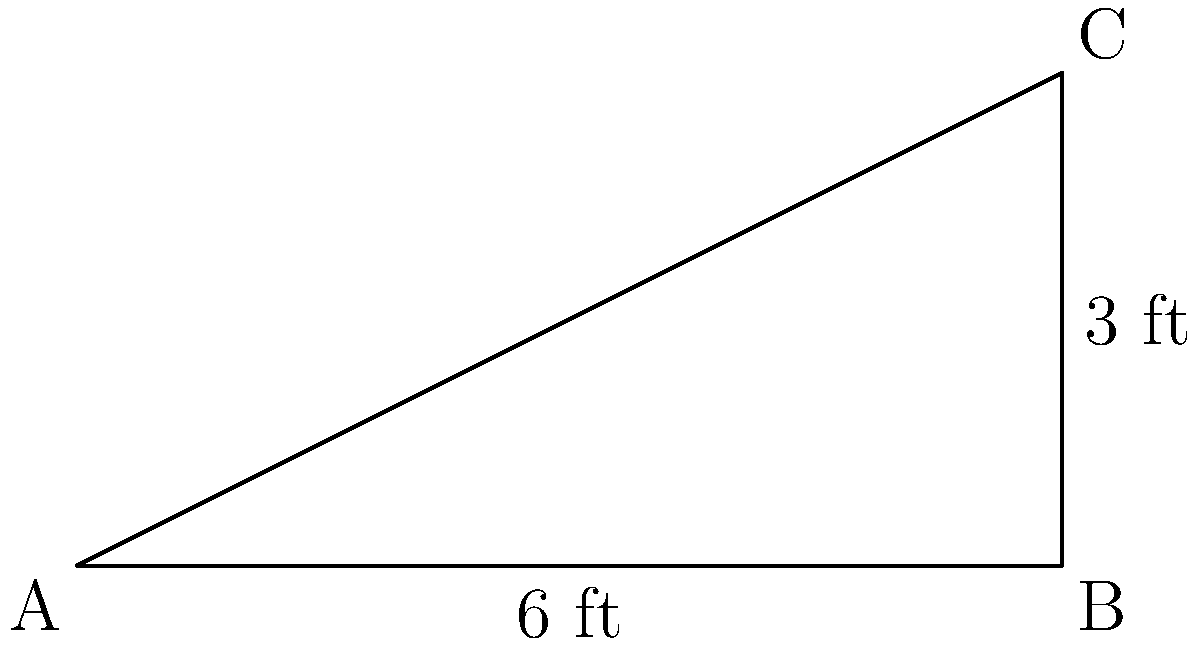As a historical buildings enthusiast, you're examining the roof of the Whittier Public Library, a historic landmark built in 1907. The roof has a rise of 3 feet over a horizontal distance (run) of 6 feet. What is the slope of this historic roof? To find the slope of the roof, we need to use the rise over run formula:

1. Identify the rise and run:
   Rise = 3 feet (vertical distance)
   Run = 6 feet (horizontal distance)

2. Apply the slope formula:
   $$ \text{Slope} = \frac{\text{Rise}}{\text{Run}} $$

3. Substitute the values:
   $$ \text{Slope} = \frac{3 \text{ feet}}{6 \text{ feet}} $$

4. Simplify the fraction:
   $$ \text{Slope} = \frac{1}{2} = 0.5 $$

5. Convert to a percentage (optional):
   $$ 0.5 \times 100\% = 50\% $$

Therefore, the slope of the historic Whittier Public Library roof is $\frac{1}{2}$ or 0.5 or 50%.
Answer: $\frac{1}{2}$ or 0.5 